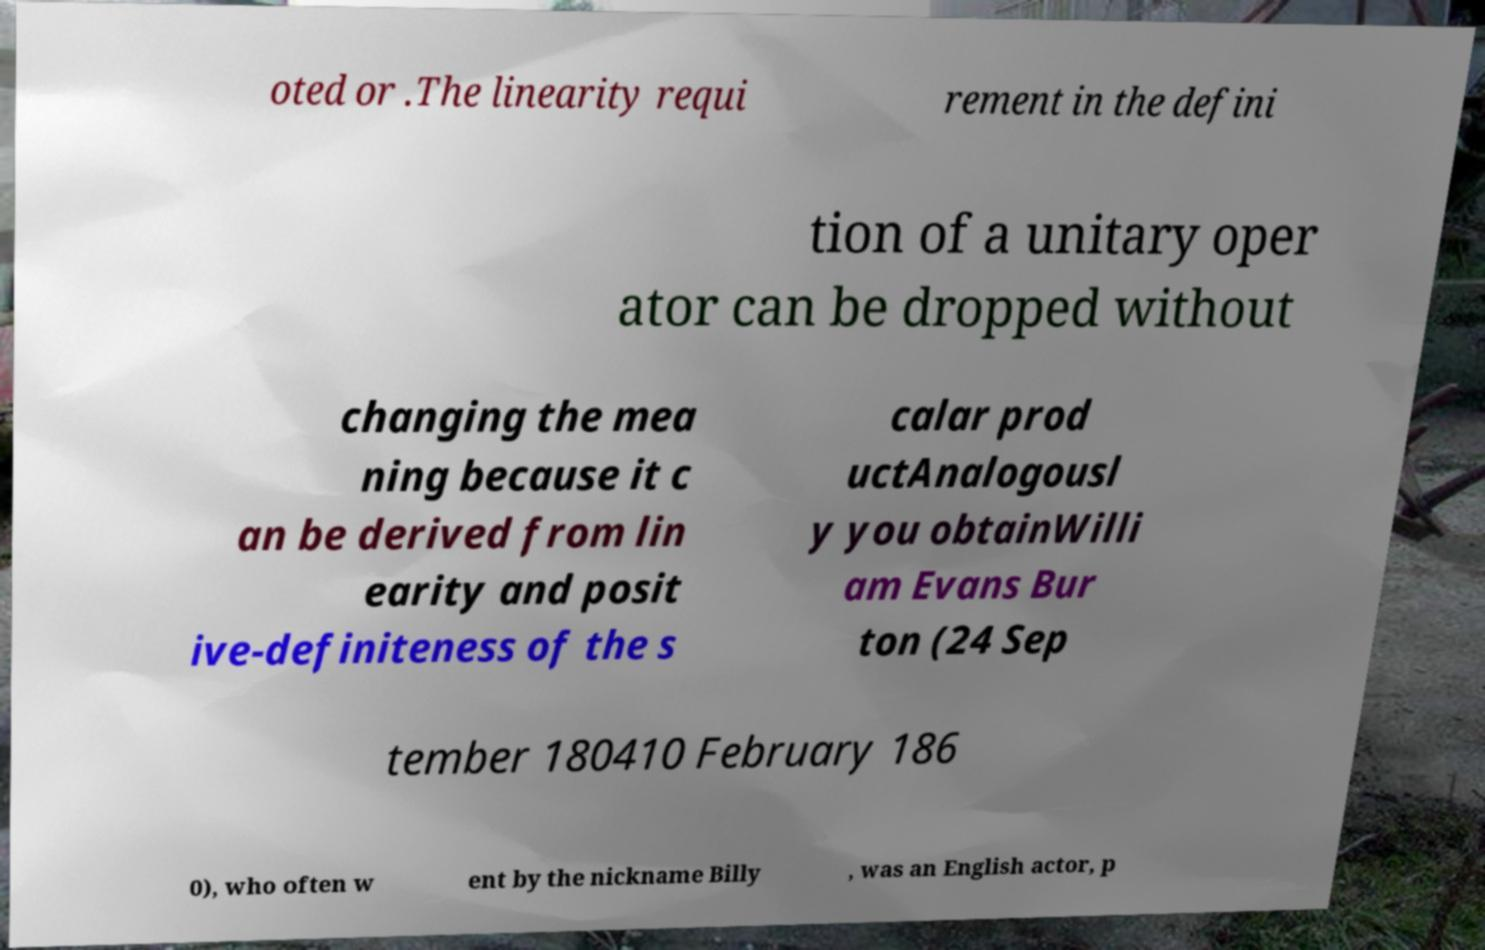Please read and relay the text visible in this image. What does it say? oted or .The linearity requi rement in the defini tion of a unitary oper ator can be dropped without changing the mea ning because it c an be derived from lin earity and posit ive-definiteness of the s calar prod uctAnalogousl y you obtainWilli am Evans Bur ton (24 Sep tember 180410 February 186 0), who often w ent by the nickname Billy , was an English actor, p 